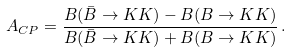Convert formula to latex. <formula><loc_0><loc_0><loc_500><loc_500>A _ { C P } = \frac { B ( { \bar { B } } \to K K ) - B ( B \to K K ) } { B ( { \bar { B } } \to K K ) + B ( B \to K K ) } \, .</formula> 